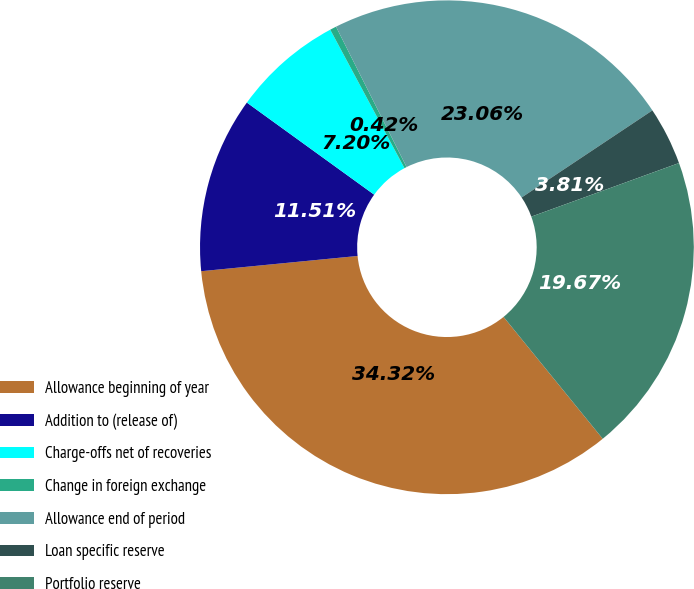Convert chart. <chart><loc_0><loc_0><loc_500><loc_500><pie_chart><fcel>Allowance beginning of year<fcel>Addition to (release of)<fcel>Charge-offs net of recoveries<fcel>Change in foreign exchange<fcel>Allowance end of period<fcel>Loan specific reserve<fcel>Portfolio reserve<nl><fcel>34.32%<fcel>11.51%<fcel>7.2%<fcel>0.42%<fcel>23.06%<fcel>3.81%<fcel>19.67%<nl></chart> 